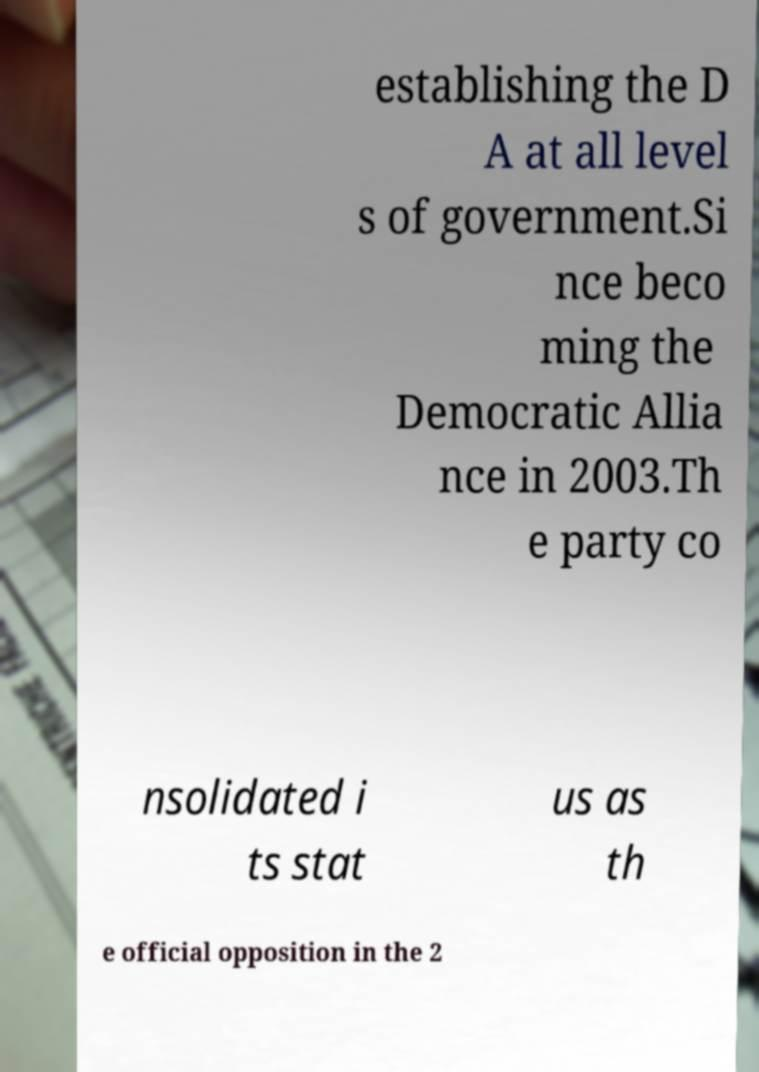There's text embedded in this image that I need extracted. Can you transcribe it verbatim? establishing the D A at all level s of government.Si nce beco ming the Democratic Allia nce in 2003.Th e party co nsolidated i ts stat us as th e official opposition in the 2 